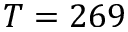<formula> <loc_0><loc_0><loc_500><loc_500>T = 2 6 9</formula> 